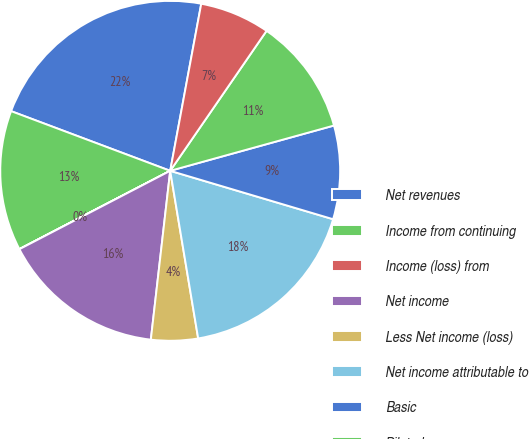Convert chart. <chart><loc_0><loc_0><loc_500><loc_500><pie_chart><fcel>Net revenues<fcel>Income from continuing<fcel>Income (loss) from<fcel>Net income<fcel>Less Net income (loss)<fcel>Net income attributable to<fcel>Basic<fcel>Diluted<fcel>High<nl><fcel>22.21%<fcel>13.33%<fcel>0.01%<fcel>15.55%<fcel>4.45%<fcel>17.77%<fcel>8.89%<fcel>11.11%<fcel>6.67%<nl></chart> 